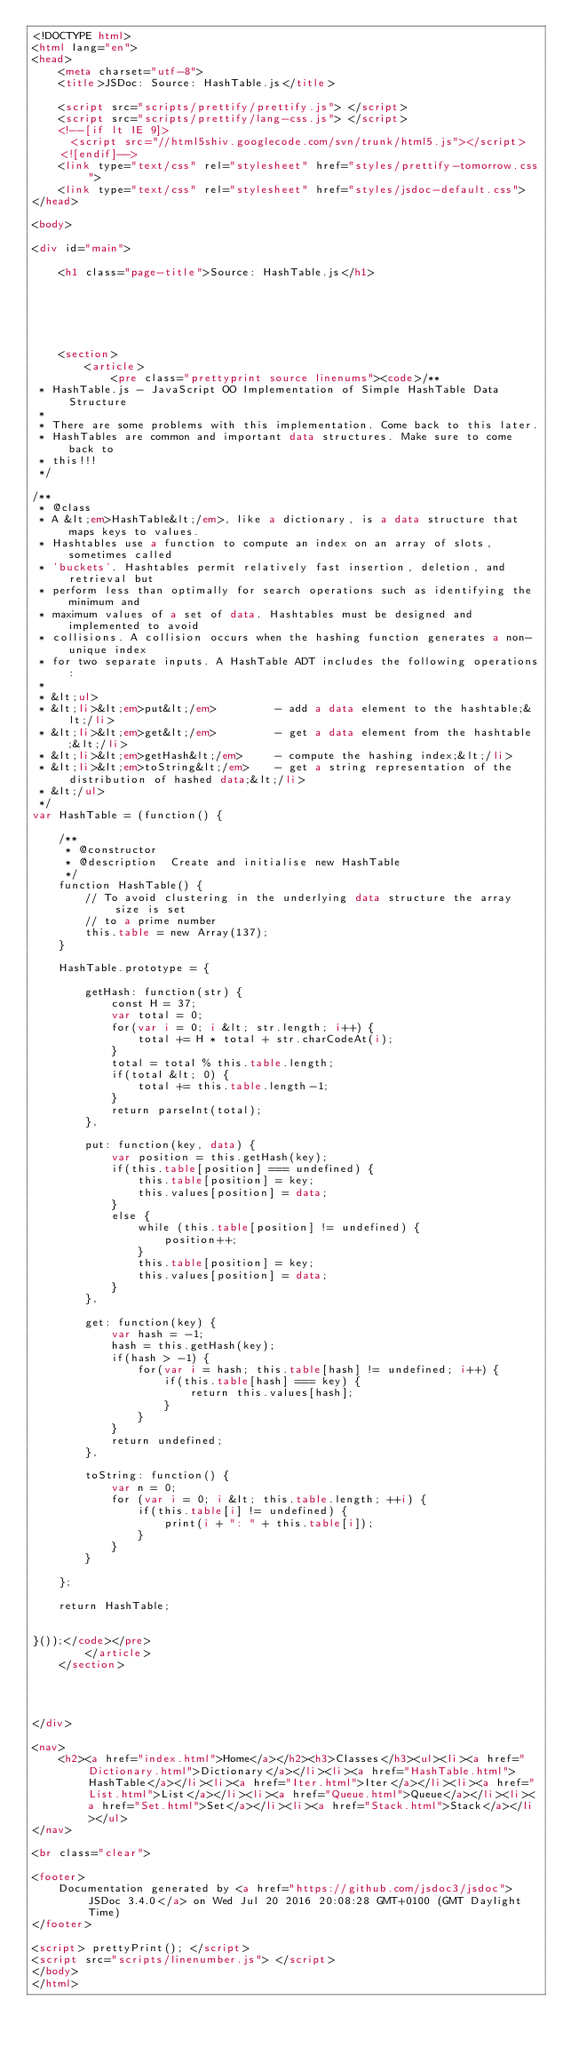<code> <loc_0><loc_0><loc_500><loc_500><_HTML_><!DOCTYPE html>
<html lang="en">
<head>
    <meta charset="utf-8">
    <title>JSDoc: Source: HashTable.js</title>

    <script src="scripts/prettify/prettify.js"> </script>
    <script src="scripts/prettify/lang-css.js"> </script>
    <!--[if lt IE 9]>
      <script src="//html5shiv.googlecode.com/svn/trunk/html5.js"></script>
    <![endif]-->
    <link type="text/css" rel="stylesheet" href="styles/prettify-tomorrow.css">
    <link type="text/css" rel="stylesheet" href="styles/jsdoc-default.css">
</head>

<body>

<div id="main">

    <h1 class="page-title">Source: HashTable.js</h1>

    



    
    <section>
        <article>
            <pre class="prettyprint source linenums"><code>/** 
 * HashTable.js - JavaScript OO Implementation of Simple HashTable Data Structure
 *
 * There are some problems with this implementation. Come back to this later. 
 * HashTables are common and important data structures. Make sure to come back to
 * this!!!
 */

/**
 * @class 
 * A &lt;em>HashTable&lt;/em>, like a dictionary, is a data structure that maps keys to values.
 * Hashtables use a function to compute an index on an array of slots, sometimes called 
 * 'buckets'. Hashtables permit relatively fast insertion, deletion, and retrieval but 
 * perform less than optimally for search operations such as identifying the minimum and 
 * maximum values of a set of data. Hashtables must be designed and implemented to avoid 
 * collisions. A collision occurs when the hashing function generates a non-unique index
 * for two separate inputs. A HashTable ADT includes the following operations:
 *
 * &lt;ul>
 * &lt;li>&lt;em>put&lt;/em>         - add a data element to the hashtable;&lt;/li>
 * &lt;li>&lt;em>get&lt;/em>         - get a data element from the hashtable;&lt;/li>
 * &lt;li>&lt;em>getHash&lt;/em>     - compute the hashing index;&lt;/li>
 * &lt;li>&lt;em>toString&lt;/em>    - get a string representation of the distribution of hashed data;&lt;/li>
 * &lt;/ul>
 */
var HashTable = (function() {

    /**
     * @constructor
     * @description  Create and initialise new HashTable
     */
    function HashTable() {
        // To avoid clustering in the underlying data structure the array size is set
        // to a prime number
        this.table = new Array(137);
    }

    HashTable.prototype = {

        getHash: function(str) {
            const H = 37;
            var total = 0; 
            for(var i = 0; i &lt; str.length; i++) {
                total += H * total + str.charCodeAt(i); 
            }
            total = total % this.table.length;
            if(total &lt; 0) {
                total += this.table.length-1;
            }
            return parseInt(total);
        },

        put: function(key, data) {
            var position = this.getHash(key);
            if(this.table[position] === undefined) {
                this.table[position] = key; 
                this.values[position] = data;
            }
            else {
                while (this.table[position] != undefined) {
                    position++;
                }
                this.table[position] = key;
                this.values[position] = data;
            }
        }, 

        get: function(key) {
            var hash = -1; 
            hash = this.getHash(key);
            if(hash > -1) {
                for(var i = hash; this.table[hash] != undefined; i++) {
                    if(this.table[hash] === key) {
                        return this.values[hash];
                    }
                }
            }
            return undefined;
        },  

        toString: function() {
            var n = 0; 
            for (var i = 0; i &lt; this.table.length; ++i) {
                if(this.table[i] != undefined) {
                    print(i + ": " + this.table[i]);
                }
            }
        }

    };

    return HashTable;


}());</code></pre>
        </article>
    </section>




</div>

<nav>
    <h2><a href="index.html">Home</a></h2><h3>Classes</h3><ul><li><a href="Dictionary.html">Dictionary</a></li><li><a href="HashTable.html">HashTable</a></li><li><a href="Iter.html">Iter</a></li><li><a href="List.html">List</a></li><li><a href="Queue.html">Queue</a></li><li><a href="Set.html">Set</a></li><li><a href="Stack.html">Stack</a></li></ul>
</nav>

<br class="clear">

<footer>
    Documentation generated by <a href="https://github.com/jsdoc3/jsdoc">JSDoc 3.4.0</a> on Wed Jul 20 2016 20:08:28 GMT+0100 (GMT Daylight Time)
</footer>

<script> prettyPrint(); </script>
<script src="scripts/linenumber.js"> </script>
</body>
</html>
</code> 